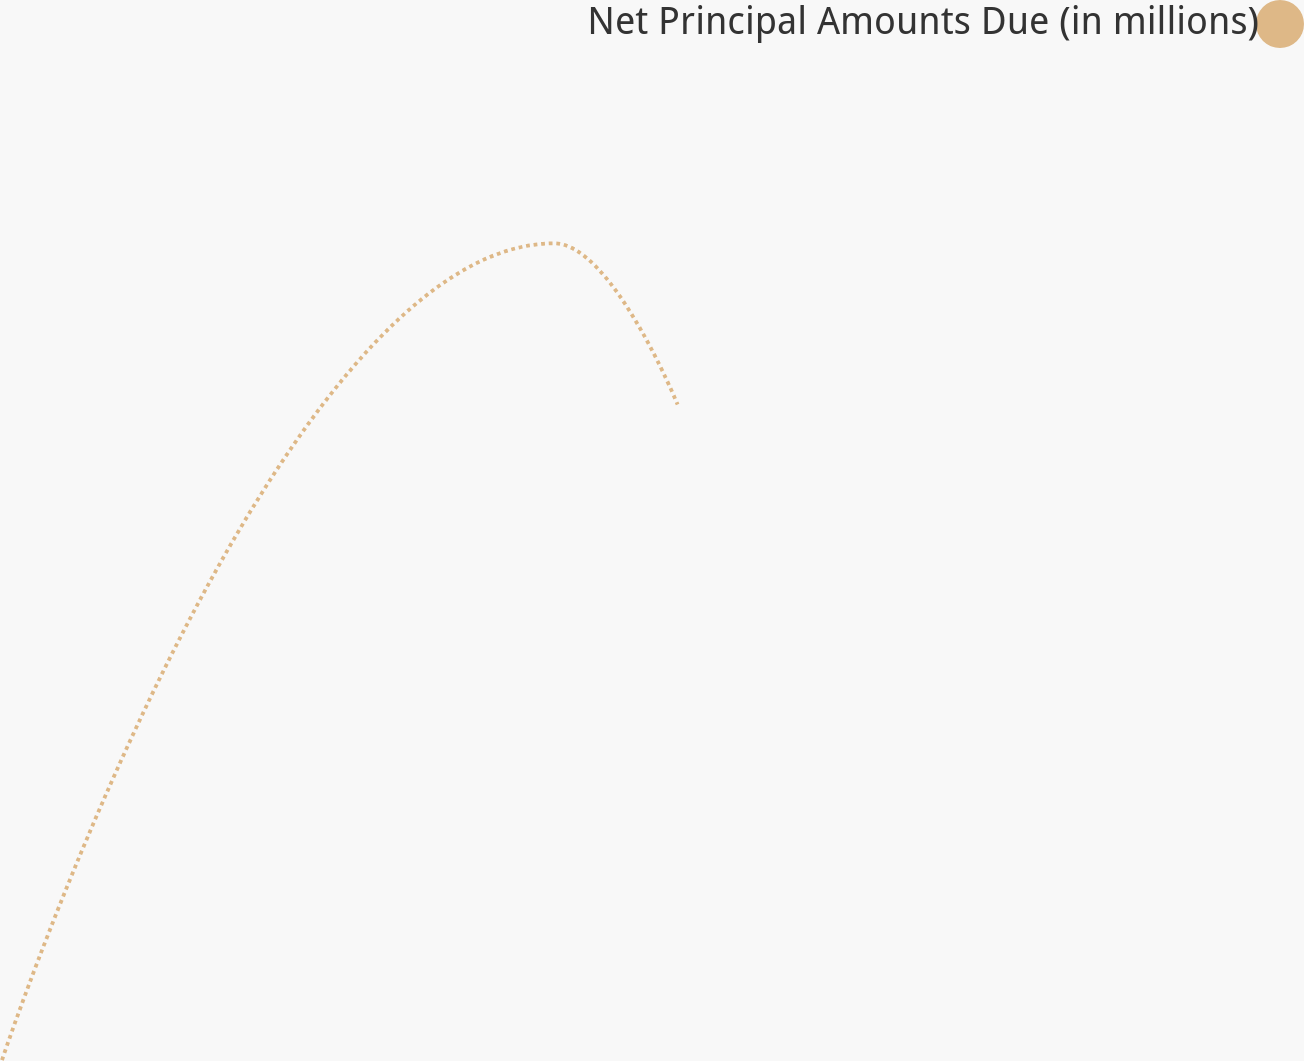Convert chart to OTSL. <chart><loc_0><loc_0><loc_500><loc_500><line_chart><ecel><fcel>Net Principal Amounts Due (in millions)<nl><fcel>1649.43<fcel>10.36<nl><fcel>1987.64<fcel>861.12<nl><fcel>2063.27<fcel>693.12<nl><fcel>2357.86<fcel>525.12<nl><fcel>2433.49<fcel>1690.35<nl></chart> 